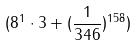Convert formula to latex. <formula><loc_0><loc_0><loc_500><loc_500>( 8 ^ { 1 } \cdot 3 + ( \frac { 1 } { 3 4 6 } ) ^ { 1 5 8 } )</formula> 